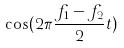<formula> <loc_0><loc_0><loc_500><loc_500>\cos ( 2 \pi \frac { f _ { 1 } - f _ { 2 } } { 2 } t )</formula> 